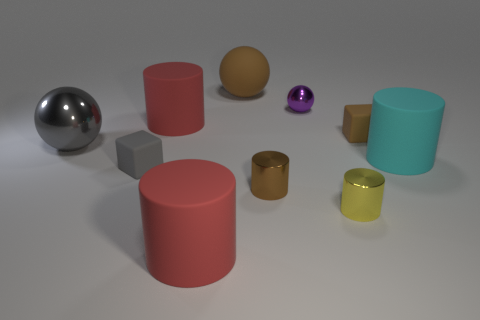There is a yellow thing that is the same size as the purple metallic thing; what shape is it?
Give a very brief answer. Cylinder. How big is the gray object that is behind the tiny gray cube?
Ensure brevity in your answer.  Large. There is a large ball that is to the left of the large brown rubber ball; is it the same color as the matte block that is left of the purple sphere?
Your answer should be compact. Yes. There is a large red cylinder behind the gray thing in front of the big matte cylinder on the right side of the big matte sphere; what is its material?
Provide a succinct answer. Rubber. Are there any blocks that have the same size as the cyan rubber cylinder?
Your response must be concise. No. What material is the brown ball that is the same size as the cyan rubber object?
Make the answer very short. Rubber. There is a brown rubber thing in front of the tiny purple shiny object; what shape is it?
Your answer should be very brief. Cube. Does the block that is to the right of the small brown shiny thing have the same material as the big cylinder right of the small yellow metal cylinder?
Keep it short and to the point. Yes. What number of other tiny metal things have the same shape as the gray metal object?
Offer a terse response. 1. There is a small cube that is the same color as the big metallic ball; what material is it?
Your answer should be compact. Rubber. 